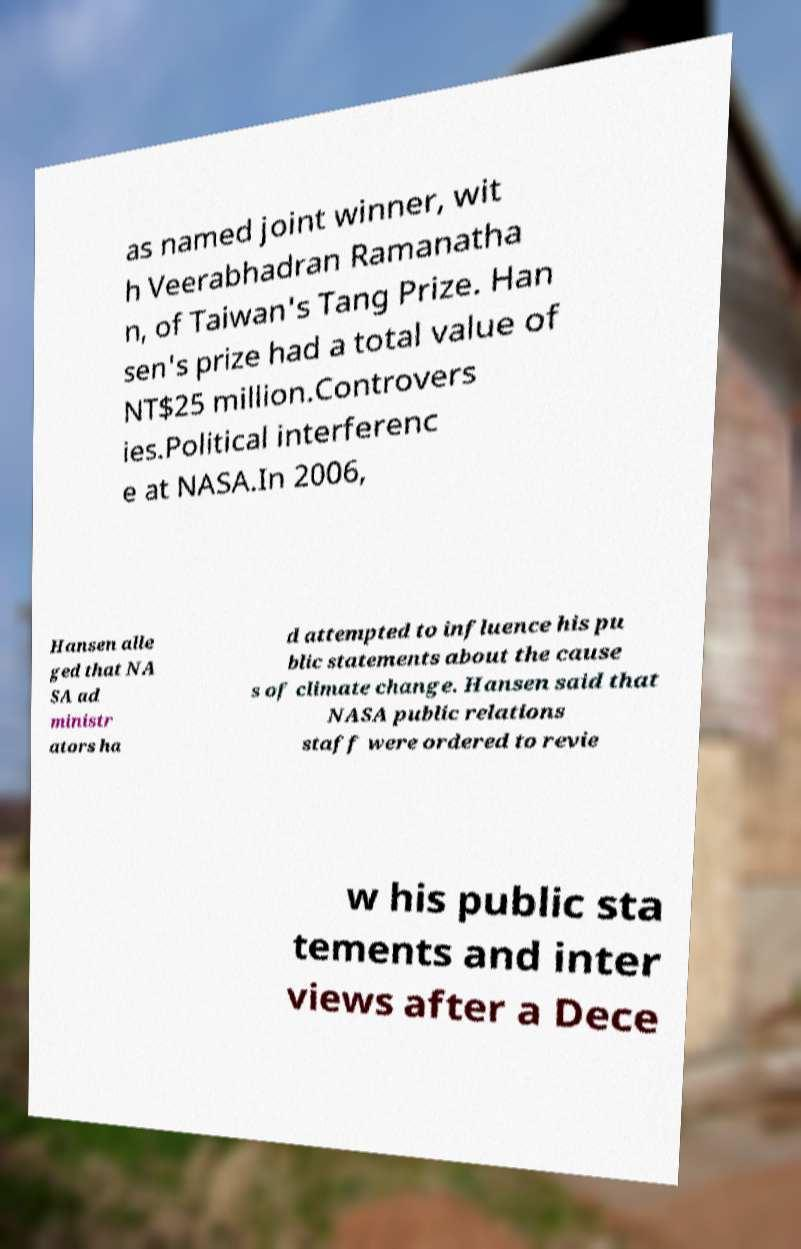I need the written content from this picture converted into text. Can you do that? as named joint winner, wit h Veerabhadran Ramanatha n, of Taiwan's Tang Prize. Han sen's prize had a total value of NT$25 million.Controvers ies.Political interferenc e at NASA.In 2006, Hansen alle ged that NA SA ad ministr ators ha d attempted to influence his pu blic statements about the cause s of climate change. Hansen said that NASA public relations staff were ordered to revie w his public sta tements and inter views after a Dece 